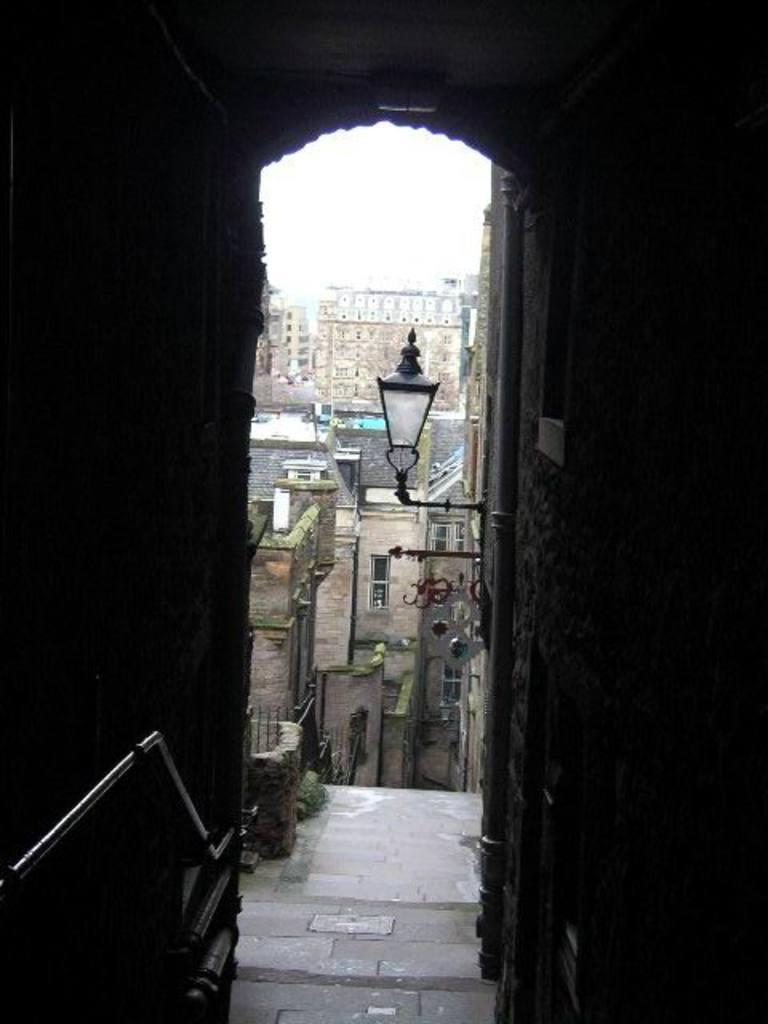What can be seen in the foreground of the image? There are buildings in the foreground of the image. What can be seen in the background of the image? There are buildings in the background of the image. What is visible in the background of the image besides buildings? There is a light visible in the background of the image. What is at the bottom of the image? There is a walkway at the bottom of the image. What type of bread can be seen being used in an argument in the image? There is no bread or argument present in the image. 